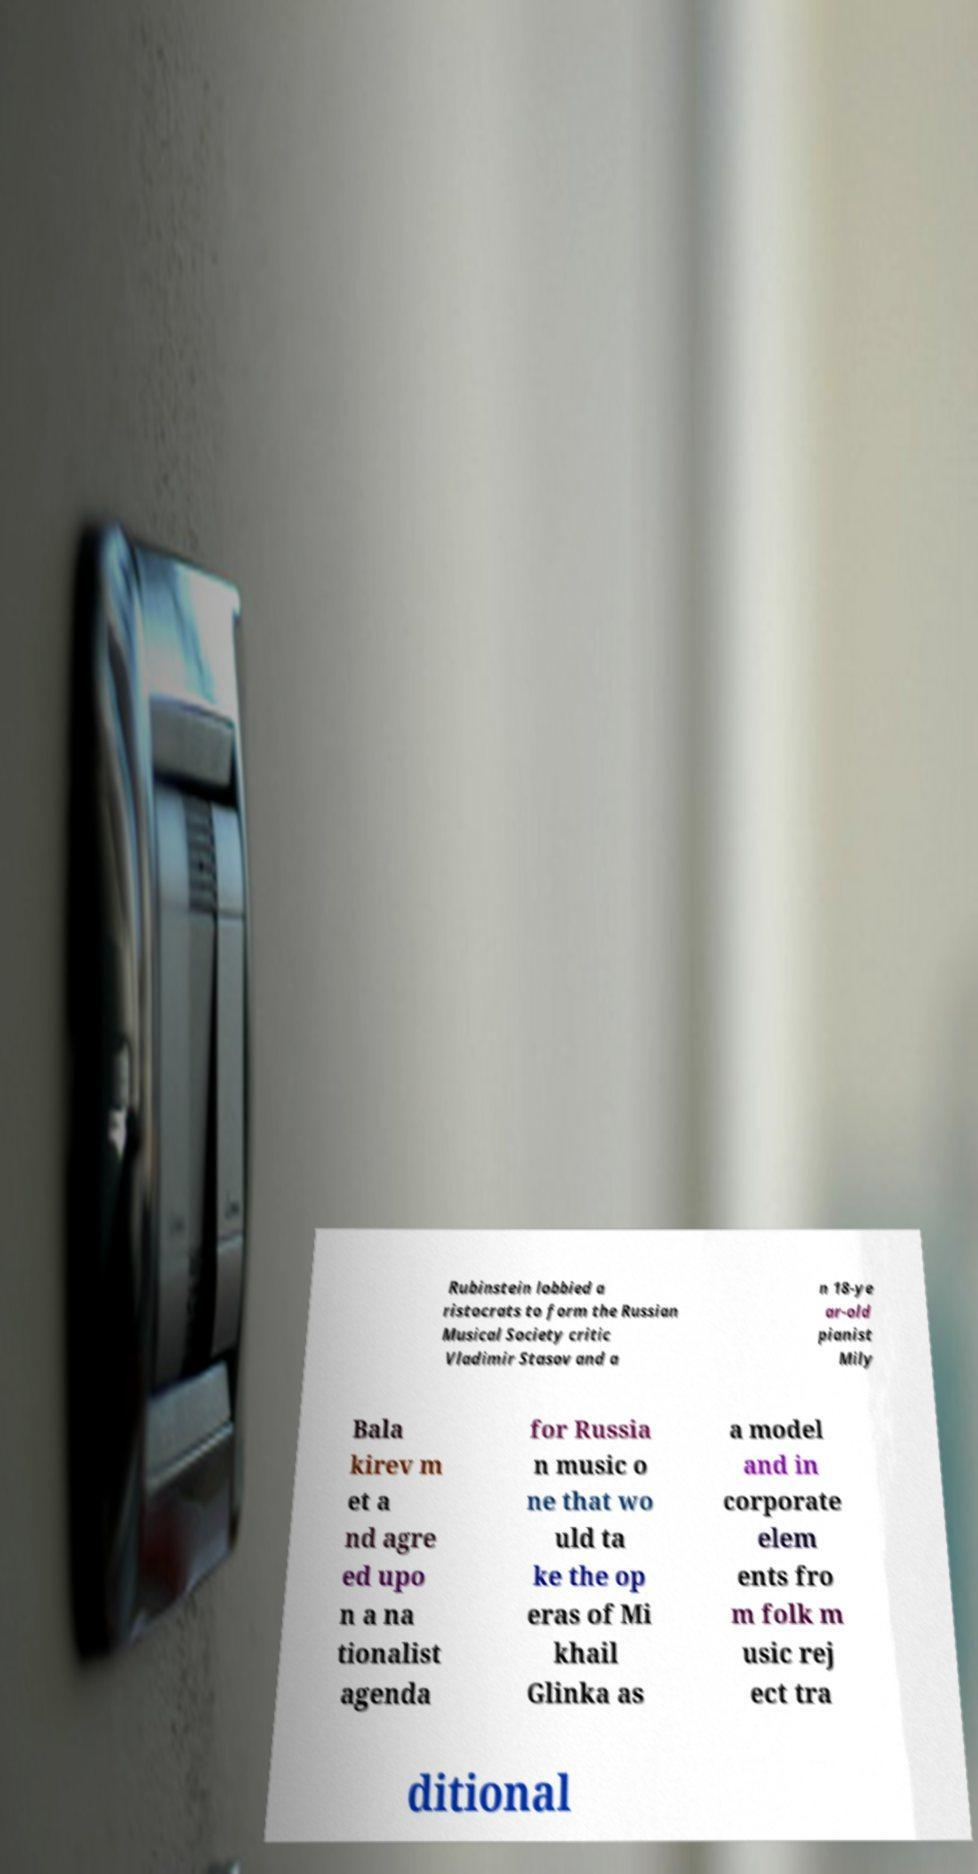What messages or text are displayed in this image? I need them in a readable, typed format. Rubinstein lobbied a ristocrats to form the Russian Musical Society critic Vladimir Stasov and a n 18-ye ar-old pianist Mily Bala kirev m et a nd agre ed upo n a na tionalist agenda for Russia n music o ne that wo uld ta ke the op eras of Mi khail Glinka as a model and in corporate elem ents fro m folk m usic rej ect tra ditional 